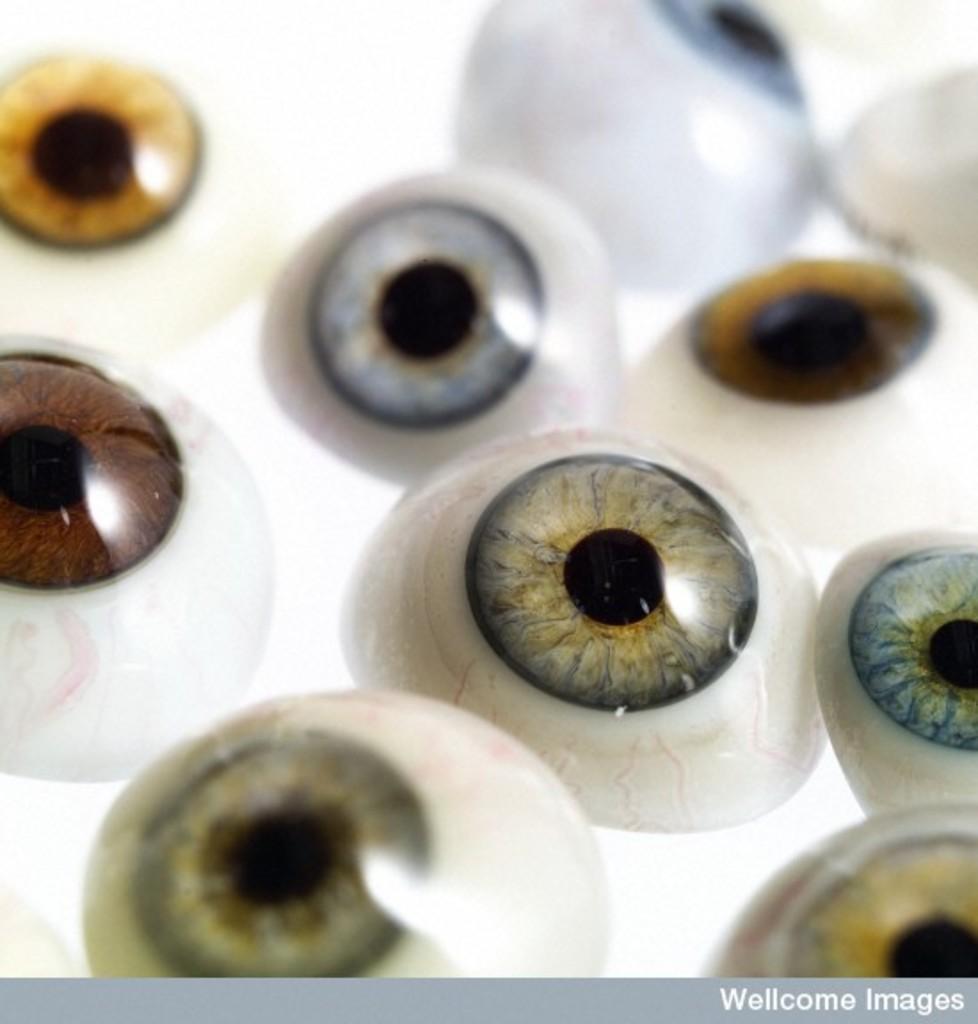Describe this image in one or two sentences. In this image we can see many eyeballs. At the bottom of the image there is border with text. 